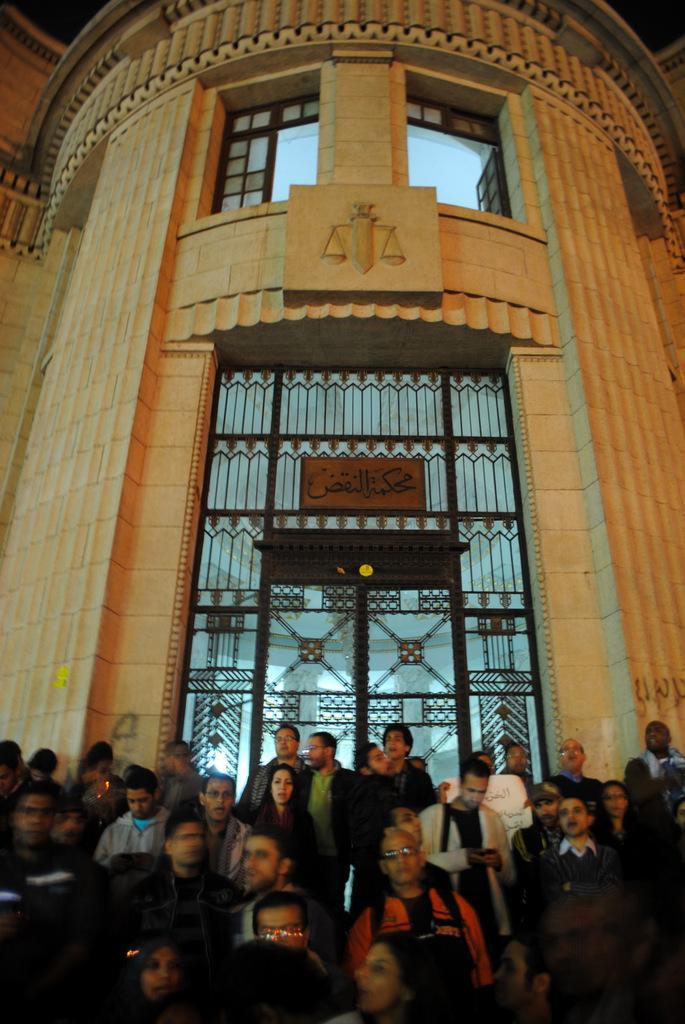Could you give a brief overview of what you see in this image? In this image there is a building towards the top of the image, there are windows, there is a door, there is a board, there is text on the board, there is a wall, there are a group of persons towards the bottom of the image. 